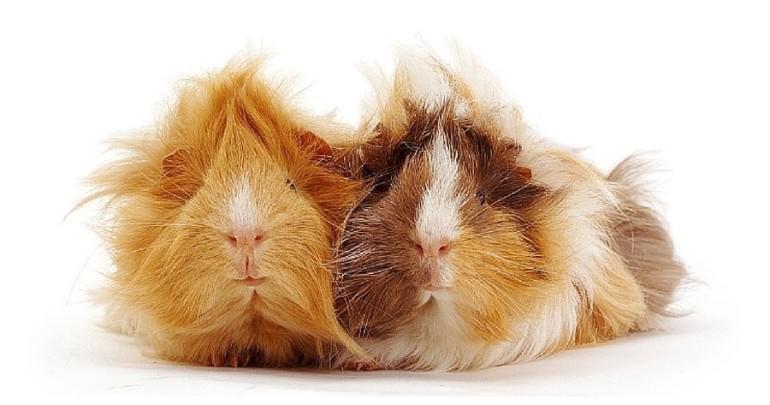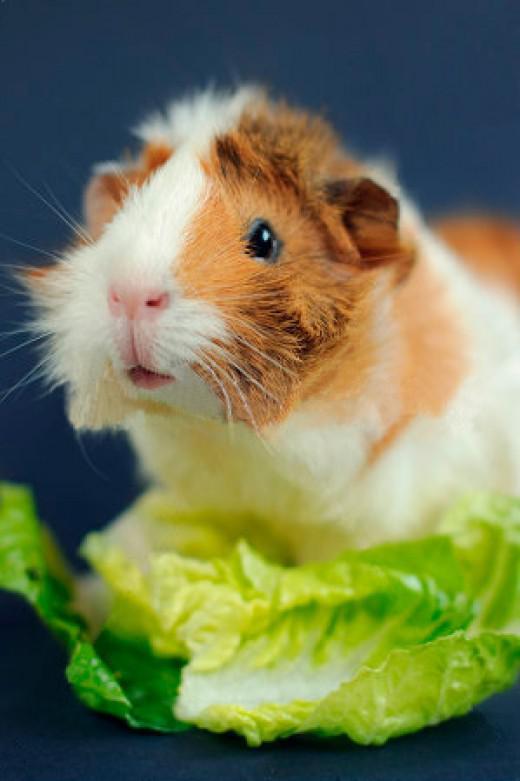The first image is the image on the left, the second image is the image on the right. Examine the images to the left and right. Is the description "There are three guinea pigs." accurate? Answer yes or no. Yes. The first image is the image on the left, the second image is the image on the right. Evaluate the accuracy of this statement regarding the images: "One image contains twice as many guinea pigs as the other hamster, and one image contains something bright green.". Is it true? Answer yes or no. Yes. 